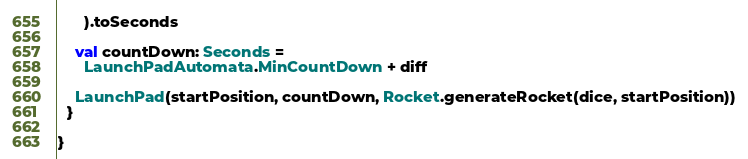Convert code to text. <code><loc_0><loc_0><loc_500><loc_500><_Scala_>      ).toSeconds

    val countDown: Seconds =
      LaunchPadAutomata.MinCountDown + diff

    LaunchPad(startPosition, countDown, Rocket.generateRocket(dice, startPosition))
  }

}
</code> 